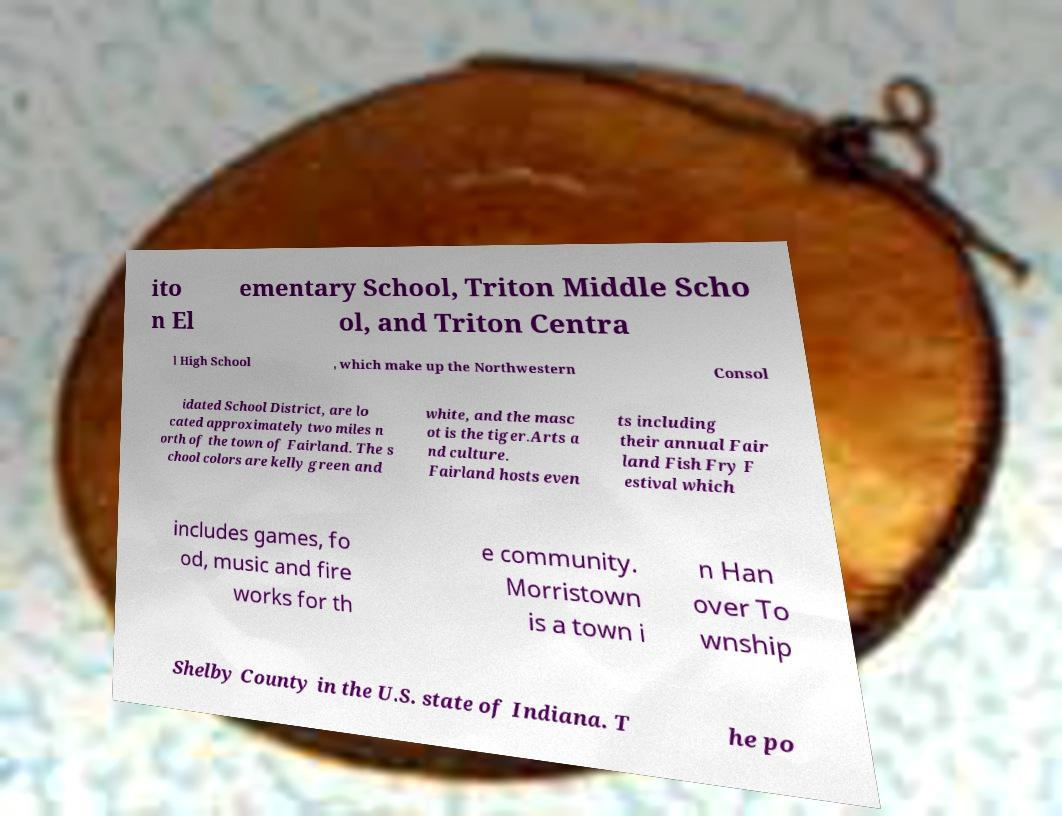Could you assist in decoding the text presented in this image and type it out clearly? ito n El ementary School, Triton Middle Scho ol, and Triton Centra l High School , which make up the Northwestern Consol idated School District, are lo cated approximately two miles n orth of the town of Fairland. The s chool colors are kelly green and white, and the masc ot is the tiger.Arts a nd culture. Fairland hosts even ts including their annual Fair land Fish Fry F estival which includes games, fo od, music and fire works for th e community. Morristown is a town i n Han over To wnship Shelby County in the U.S. state of Indiana. T he po 